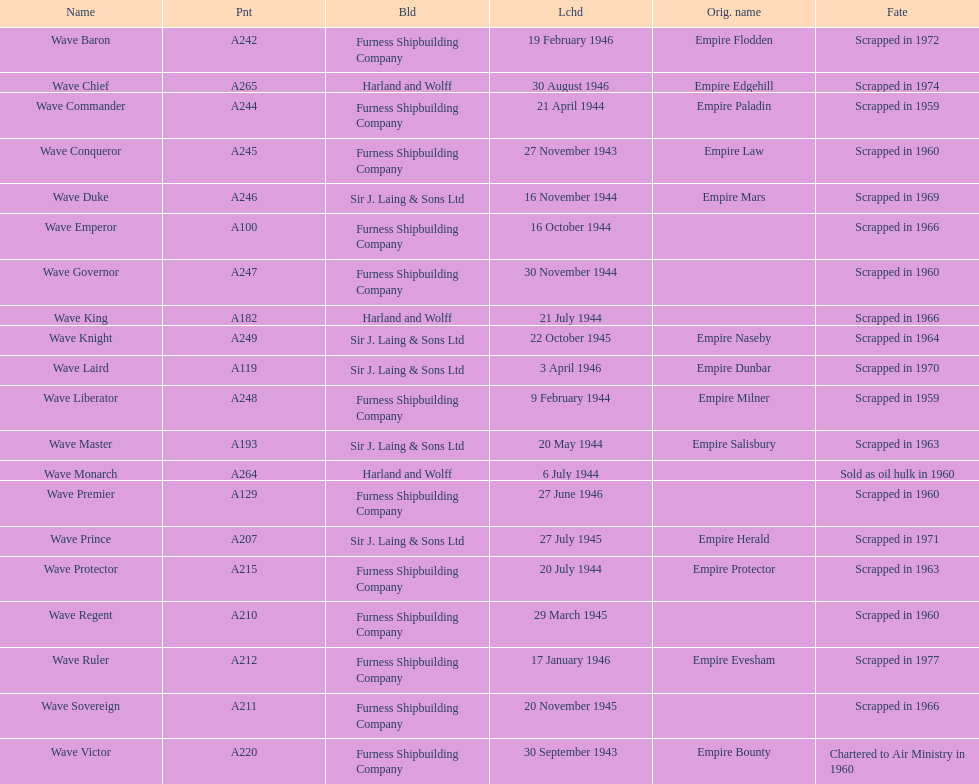What was the next wave class oiler after wave emperor? Wave Duke. 